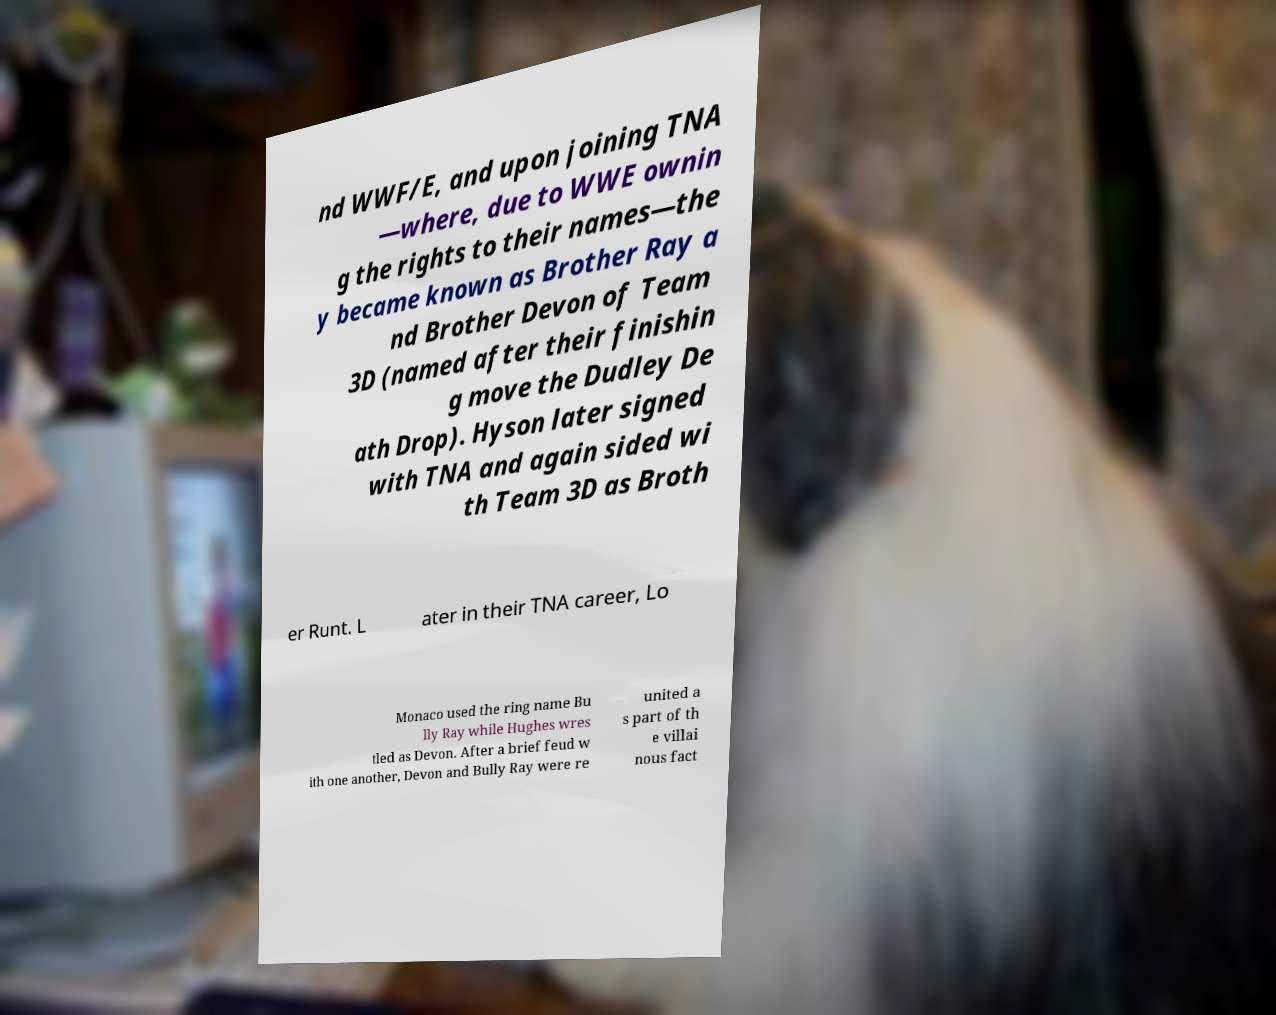There's text embedded in this image that I need extracted. Can you transcribe it verbatim? nd WWF/E, and upon joining TNA —where, due to WWE ownin g the rights to their names—the y became known as Brother Ray a nd Brother Devon of Team 3D (named after their finishin g move the Dudley De ath Drop). Hyson later signed with TNA and again sided wi th Team 3D as Broth er Runt. L ater in their TNA career, Lo Monaco used the ring name Bu lly Ray while Hughes wres tled as Devon. After a brief feud w ith one another, Devon and Bully Ray were re united a s part of th e villai nous fact 